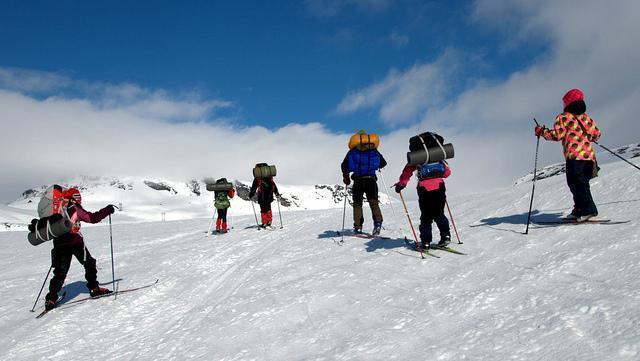Where are they going?
From the following four choices, select the correct answer to address the question.
Options: Rest stop, home, lunch, uphill. Uphill. 